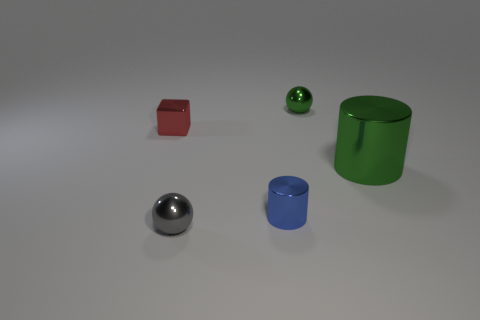Add 4 small gray matte objects. How many objects exist? 9 Subtract all blocks. How many objects are left? 4 Subtract all big green metallic things. Subtract all tiny green metal balls. How many objects are left? 3 Add 5 small red objects. How many small red objects are left? 6 Add 4 small gray shiny objects. How many small gray shiny objects exist? 5 Subtract 0 gray blocks. How many objects are left? 5 